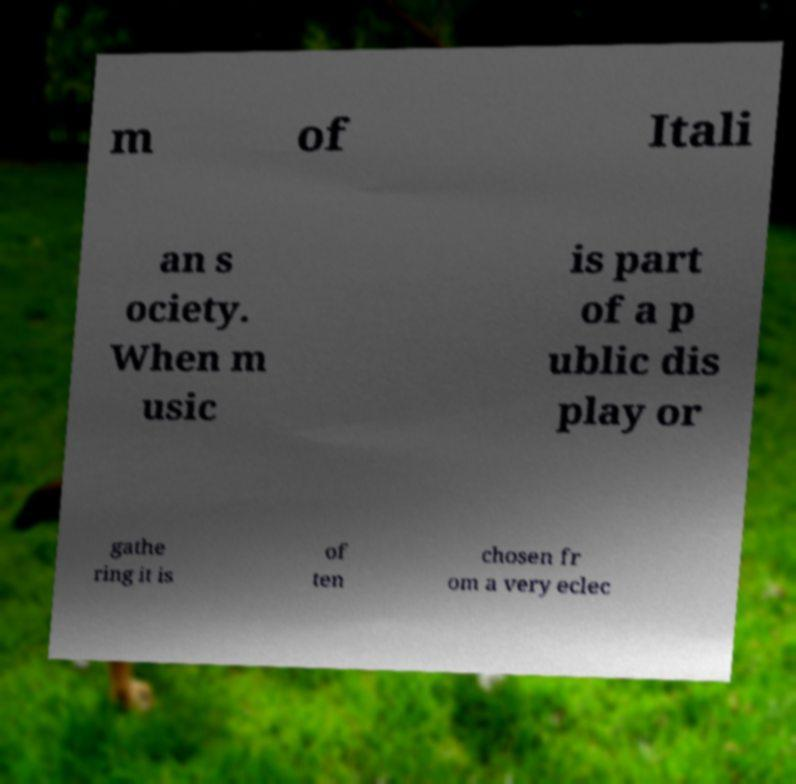Can you read and provide the text displayed in the image?This photo seems to have some interesting text. Can you extract and type it out for me? m of Itali an s ociety. When m usic is part of a p ublic dis play or gathe ring it is of ten chosen fr om a very eclec 